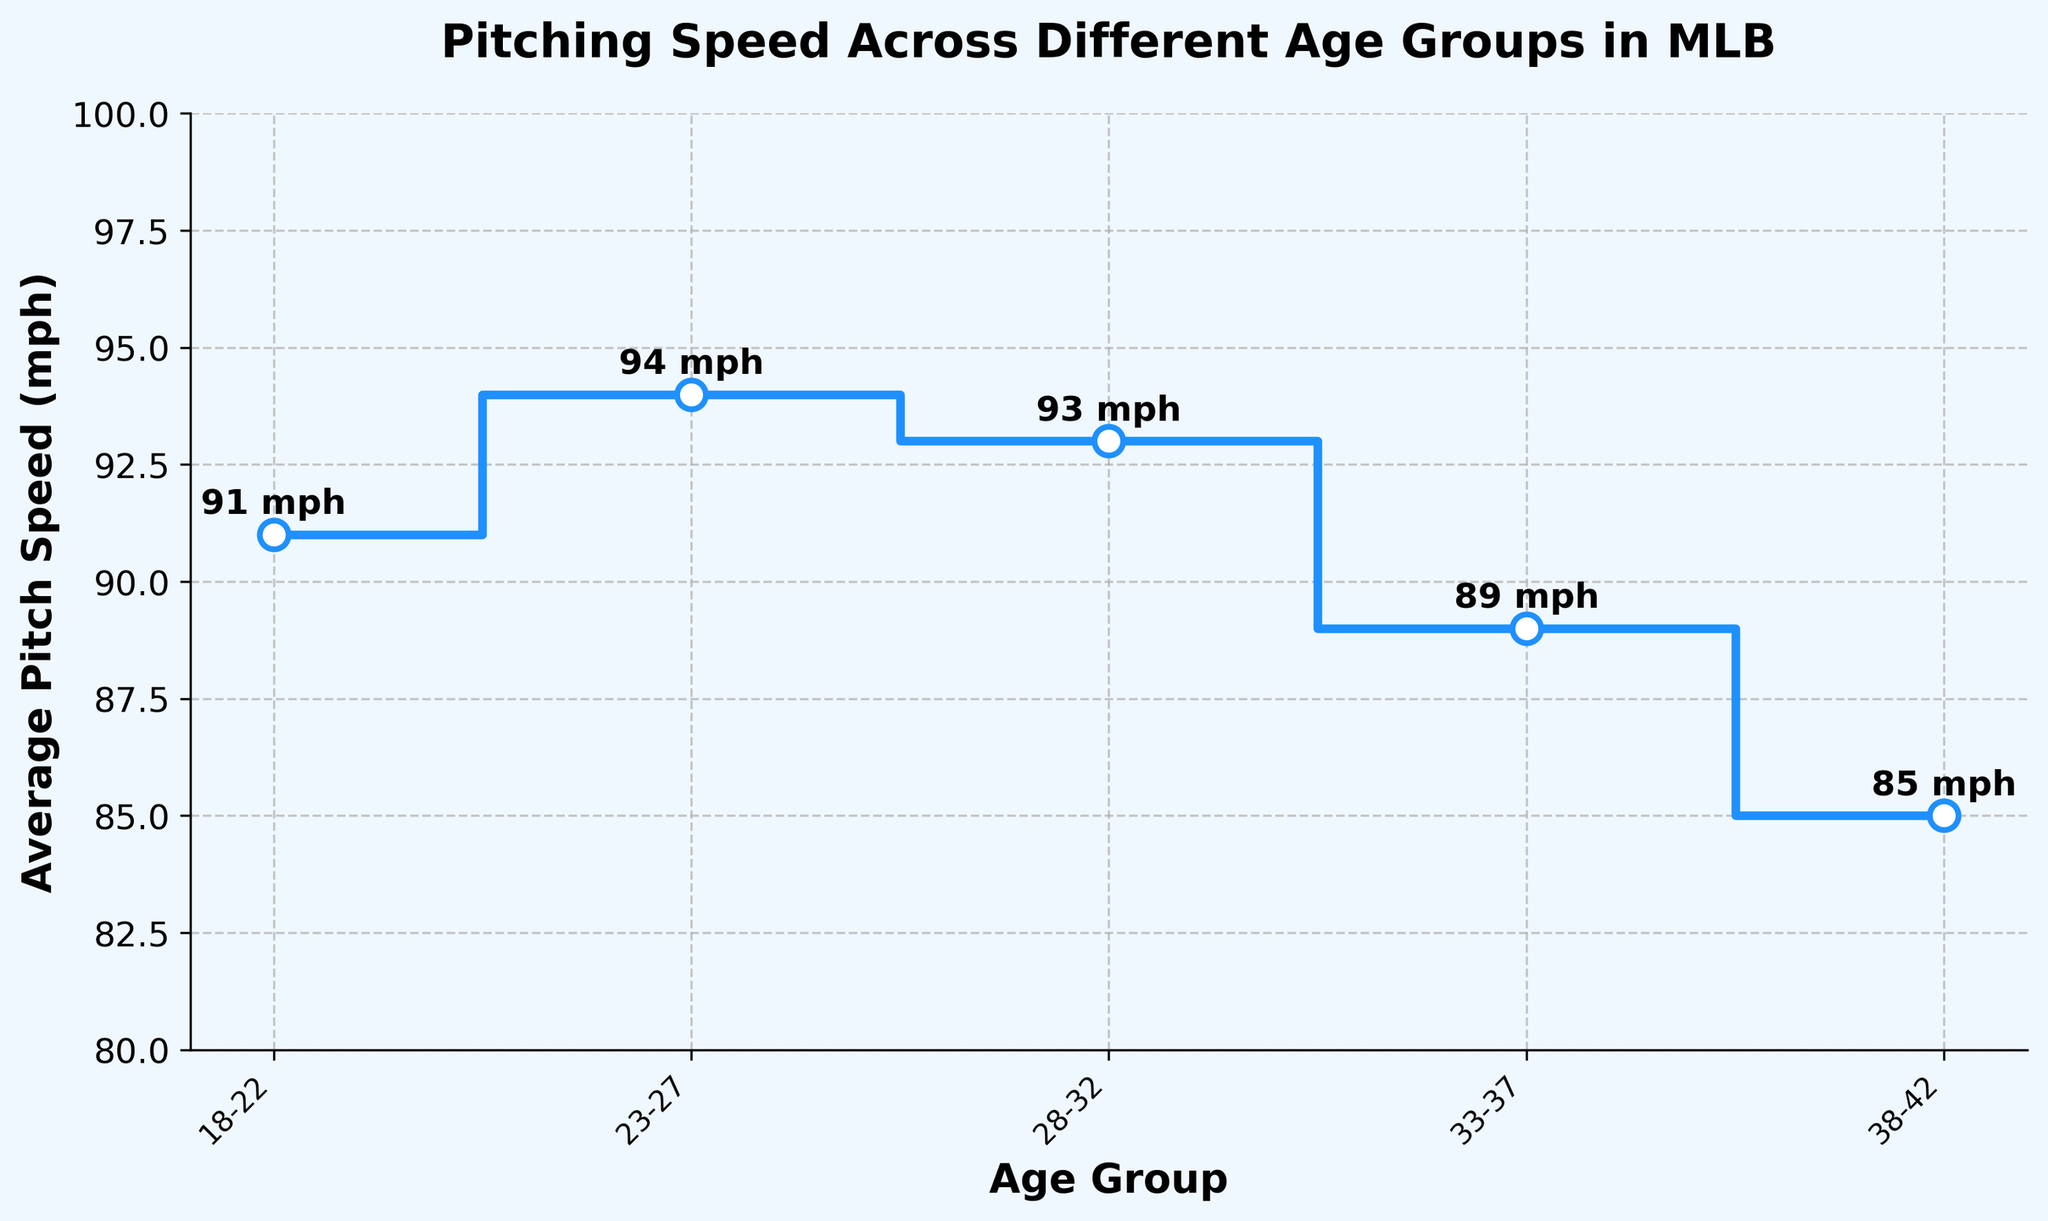What's the title of the plot? The title of the plot is displayed at the top of the figure. It gives an overview of what the plot is about.
Answer: Pitching Speed Across Different Age Groups in MLB What are the age groups represented on the plot? The age groups are labeled on the x-axis. These labels indicate different ranges of ages for the players.
Answer: 18-22, 23-27, 28-32, 33-37, 38-42 What is the average pitch speed for the 23-27 age group? Look at the data point on the y-axis that corresponds to the age group 23-27 on the x-axis.
Answer: 94 mph Which age group has the highest average pitch speed? Identify the bar or line segment that reaches the highest point on the y-axis.
Answer: 23-27 How does the average pitch speed change from the 28-32 age group to the 33-37 age group? Find the average pitch speeds for these two age groups and then calculate the difference.
Answer: It decreases by 4 mph (from 93 mph to 89 mph) What is the overall trend in average pitch speed as age increases? Observe the pattern of the data points from left to right, noting whether the values generally increase, decrease, or stay the same.
Answer: The average pitch speed generally decreases as age increases Which age group displays the largest drop in average pitch speed from the previous group? Calculate the differences in average pitch speeds between consecutive age groups and find the largest negative value.
Answer: From 33-37 to 38-42 (a drop of 4 mph) What is the combined average pitch speed for the 18-22 and 38-42 age groups? Add the average pitch speeds of the 18-22 group and the 38-42 group, then divide by 2.
Answer: (91 + 85) / 2 = 88 mph How many different data points are represented in the plot? Count the number of data points or age groups shown on the plot.
Answer: 5 What is the average pitch speed difference between the youngest (18-22) and oldest (38-42) age groups? Subtract the average pitch speed of the oldest age group from that of the youngest age group.
Answer: 91 mph - 85 mph = 6 mph 